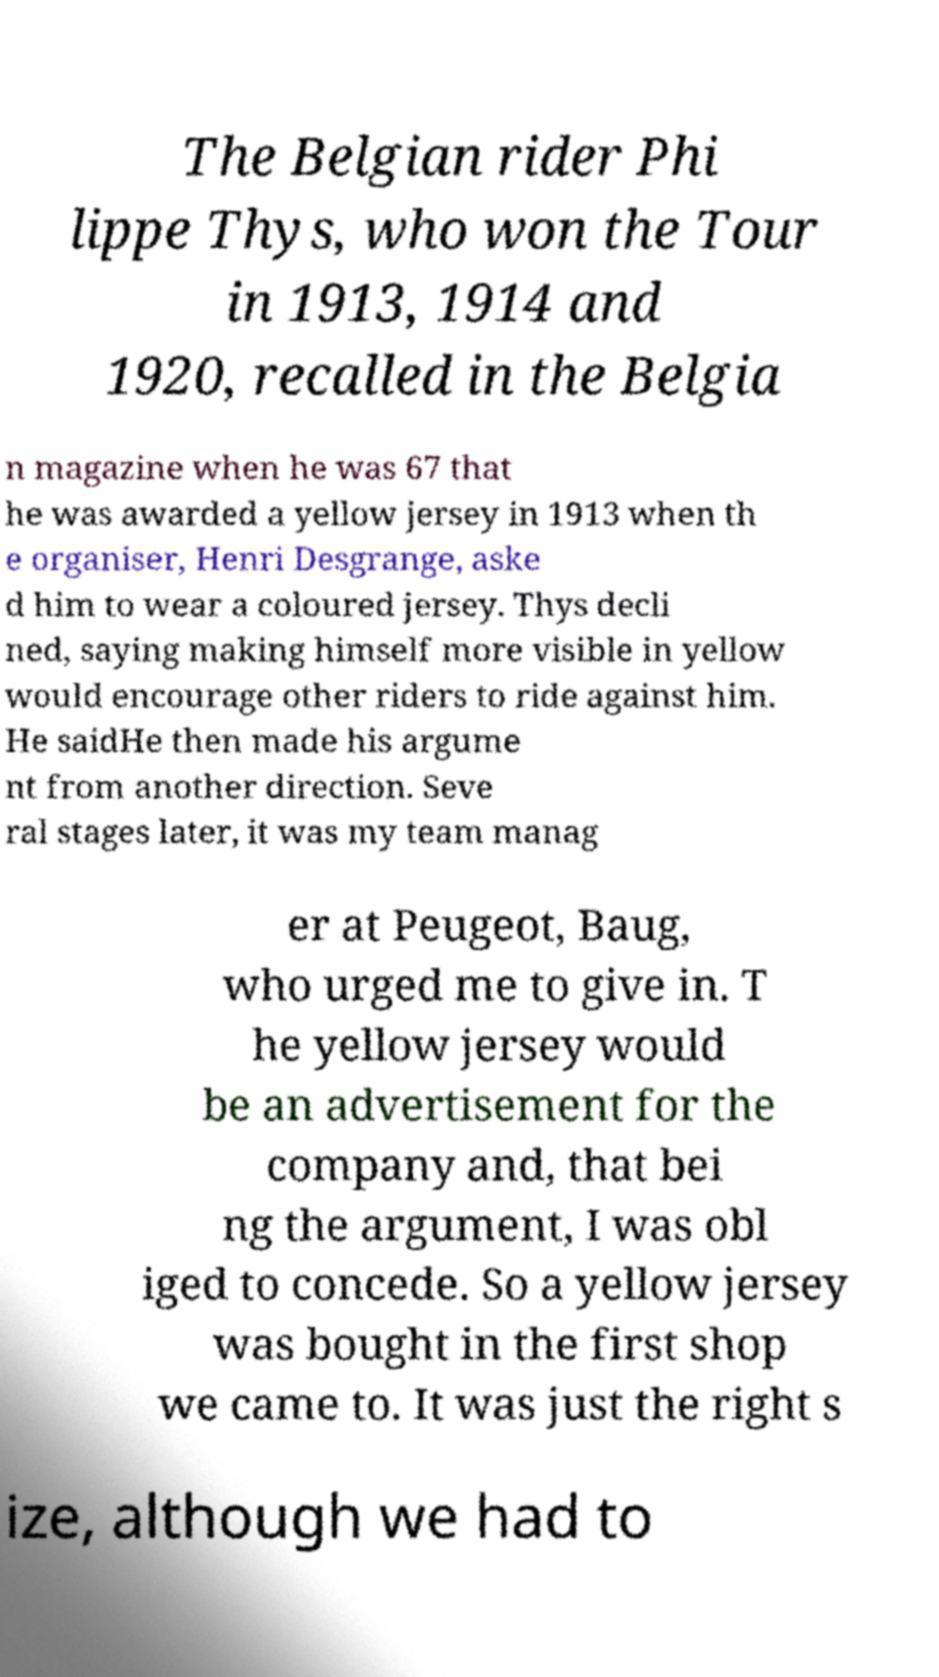Can you read and provide the text displayed in the image?This photo seems to have some interesting text. Can you extract and type it out for me? The Belgian rider Phi lippe Thys, who won the Tour in 1913, 1914 and 1920, recalled in the Belgia n magazine when he was 67 that he was awarded a yellow jersey in 1913 when th e organiser, Henri Desgrange, aske d him to wear a coloured jersey. Thys decli ned, saying making himself more visible in yellow would encourage other riders to ride against him. He saidHe then made his argume nt from another direction. Seve ral stages later, it was my team manag er at Peugeot, Baug, who urged me to give in. T he yellow jersey would be an advertisement for the company and, that bei ng the argument, I was obl iged to concede. So a yellow jersey was bought in the first shop we came to. It was just the right s ize, although we had to 